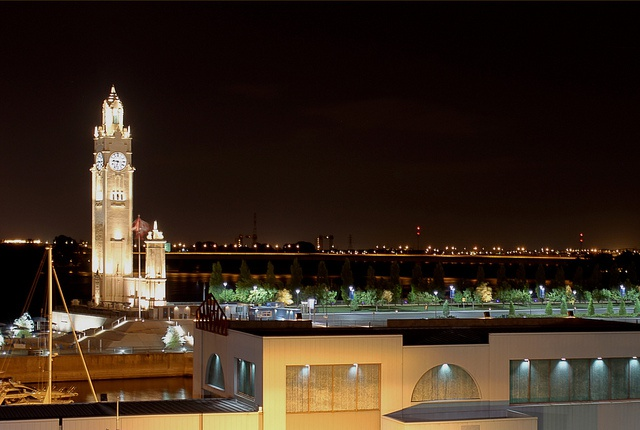Describe the objects in this image and their specific colors. I can see boat in black, brown, maroon, and orange tones, clock in black, lightgray, darkgray, tan, and gray tones, and clock in black, lightgray, darkgray, and gray tones in this image. 